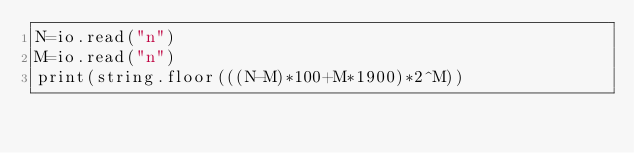Convert code to text. <code><loc_0><loc_0><loc_500><loc_500><_Lua_>N=io.read("n")
M=io.read("n")
print(string.floor(((N-M)*100+M*1900)*2^M))</code> 